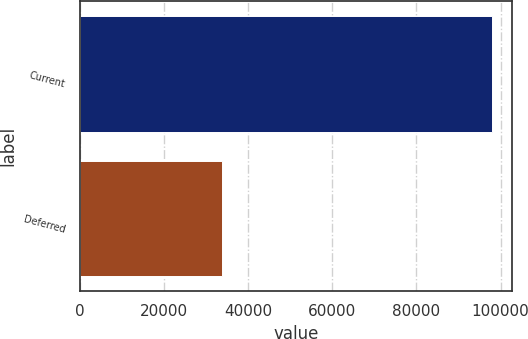<chart> <loc_0><loc_0><loc_500><loc_500><bar_chart><fcel>Current<fcel>Deferred<nl><fcel>97834<fcel>33808<nl></chart> 